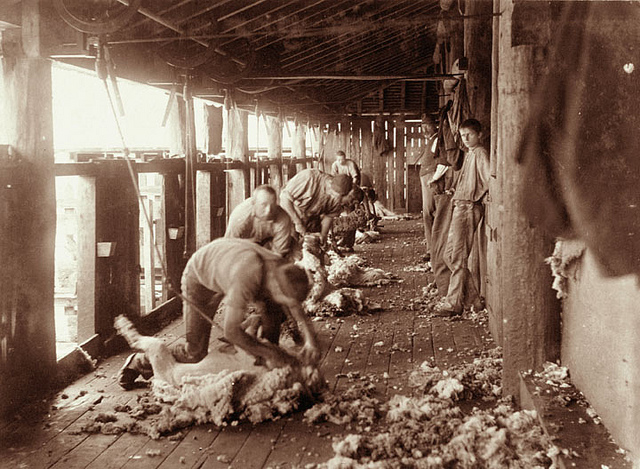<image>What are the men in this picture doing? It is unknown what the men in the picture are doing. However, it is suggested they may be shearing sheep. What are the men in this picture doing? It is unanswerable what the men in the picture are doing. 